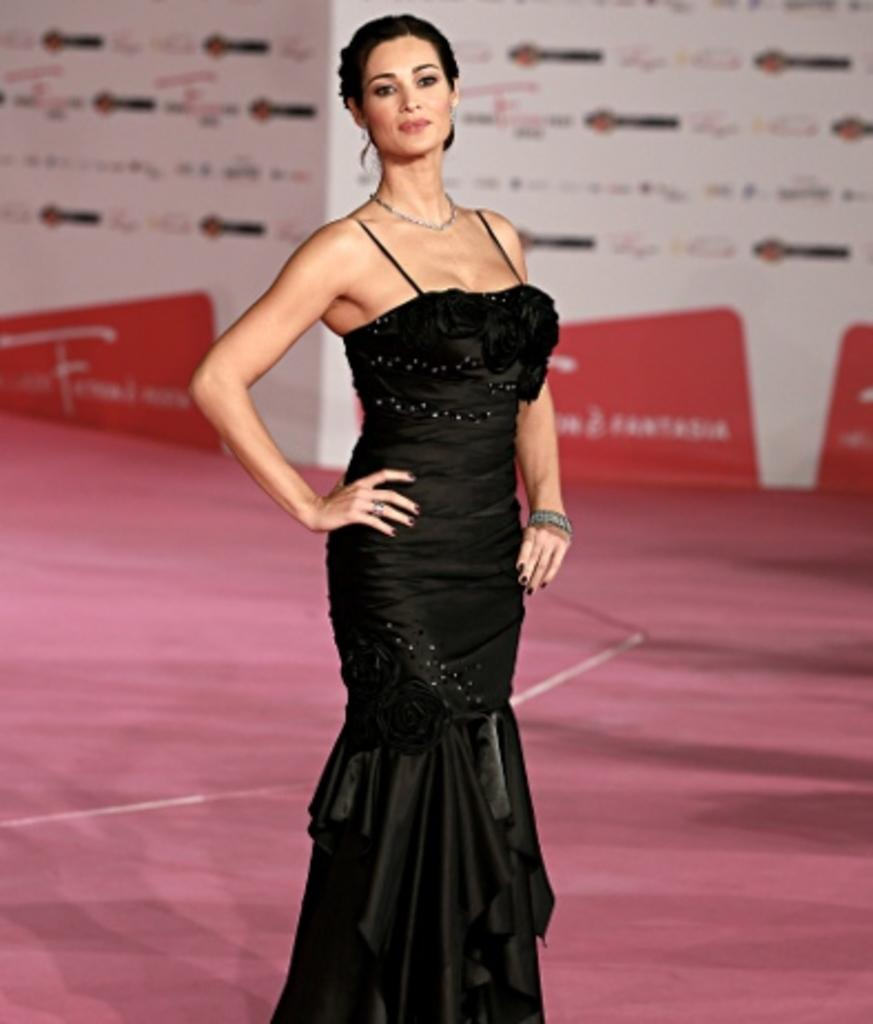Who is the main subject in the image? There is a woman in the image. Where is the woman positioned in the picture? The woman is standing in the center of the picture. What is the woman wearing? The woman is wearing a black dress. What is the woman standing on? The woman is standing on a red carpet. What can be seen in the background of the image? There are banners in the background of the image. Is the man in the image using his knee to support the woman? There is no man present in the image, and the woman is standing on her own without any support. 